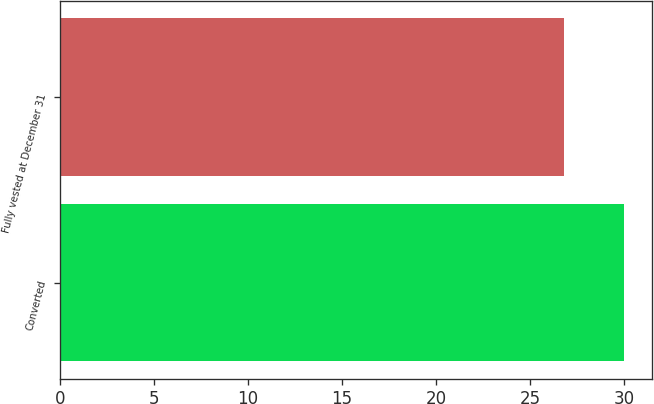Convert chart. <chart><loc_0><loc_0><loc_500><loc_500><bar_chart><fcel>Converted<fcel>Fully vested at December 31<nl><fcel>30<fcel>26.8<nl></chart> 